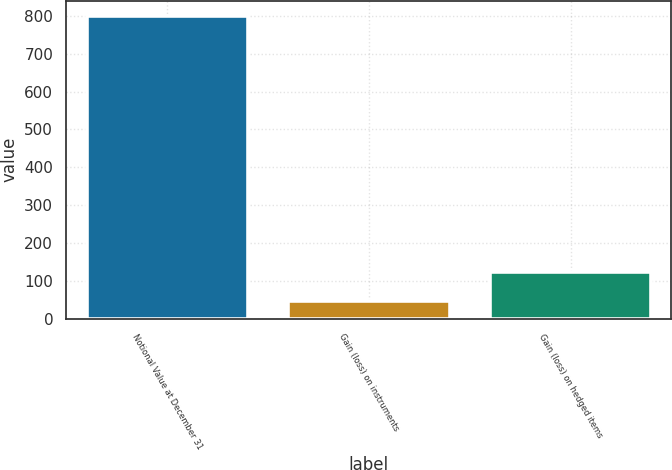<chart> <loc_0><loc_0><loc_500><loc_500><bar_chart><fcel>Notional Value at December 31<fcel>Gain (loss) on instruments<fcel>Gain (loss) on hedged items<nl><fcel>800<fcel>48<fcel>123.2<nl></chart> 